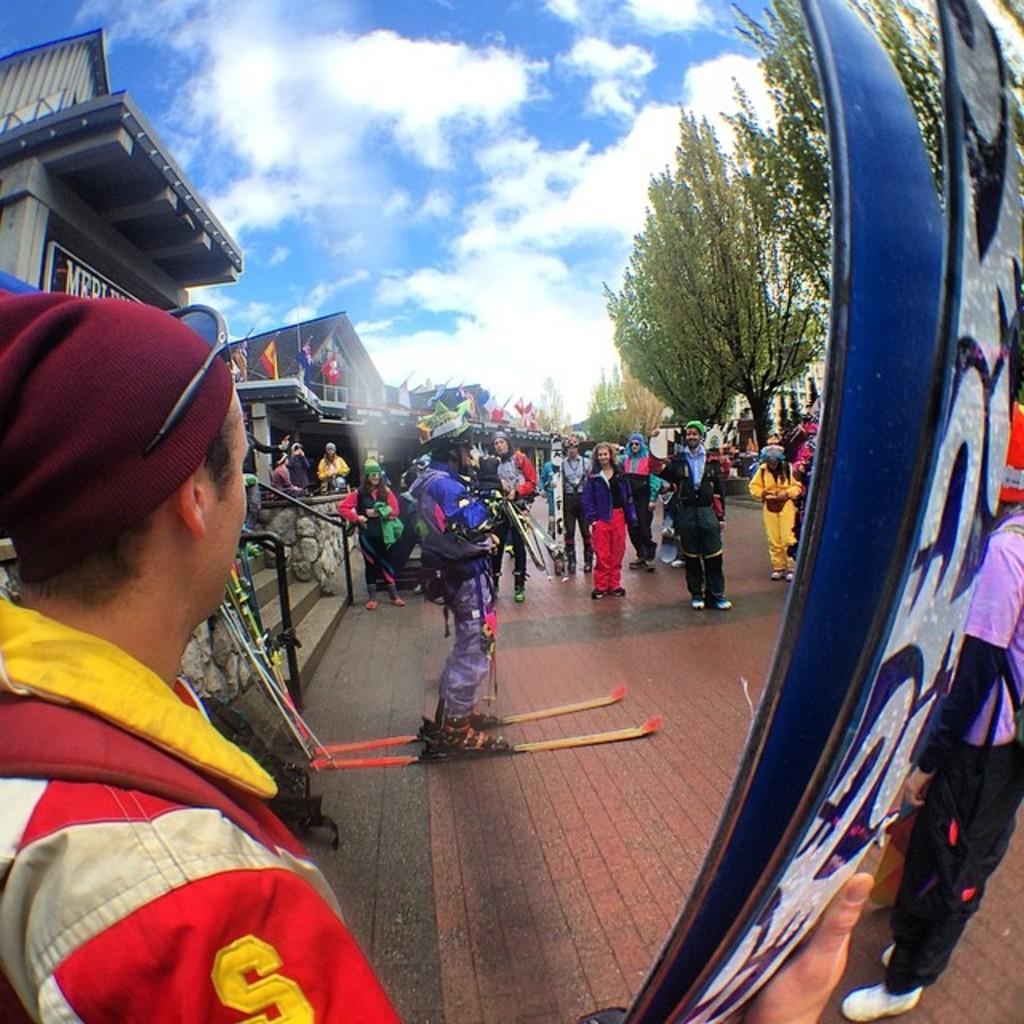What letter is shown on the left person's sleeve?
Your answer should be very brief. S. 